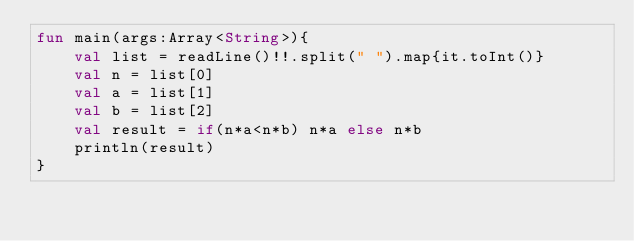Convert code to text. <code><loc_0><loc_0><loc_500><loc_500><_Kotlin_>fun main(args:Array<String>){
    val list = readLine()!!.split(" ").map{it.toInt()}
    val n = list[0]
    val a = list[1]
    val b = list[2]
    val result = if(n*a<n*b) n*a else n*b
    println(result)
}</code> 